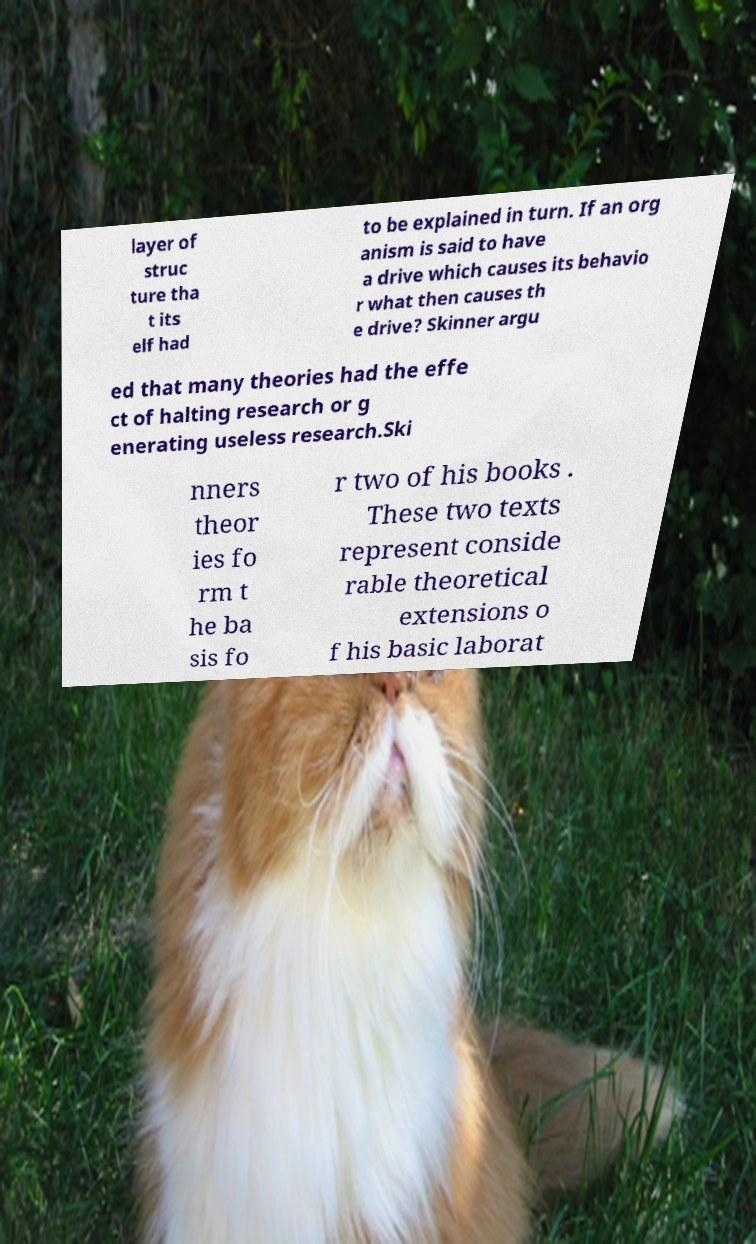There's text embedded in this image that I need extracted. Can you transcribe it verbatim? layer of struc ture tha t its elf had to be explained in turn. If an org anism is said to have a drive which causes its behavio r what then causes th e drive? Skinner argu ed that many theories had the effe ct of halting research or g enerating useless research.Ski nners theor ies fo rm t he ba sis fo r two of his books . These two texts represent conside rable theoretical extensions o f his basic laborat 